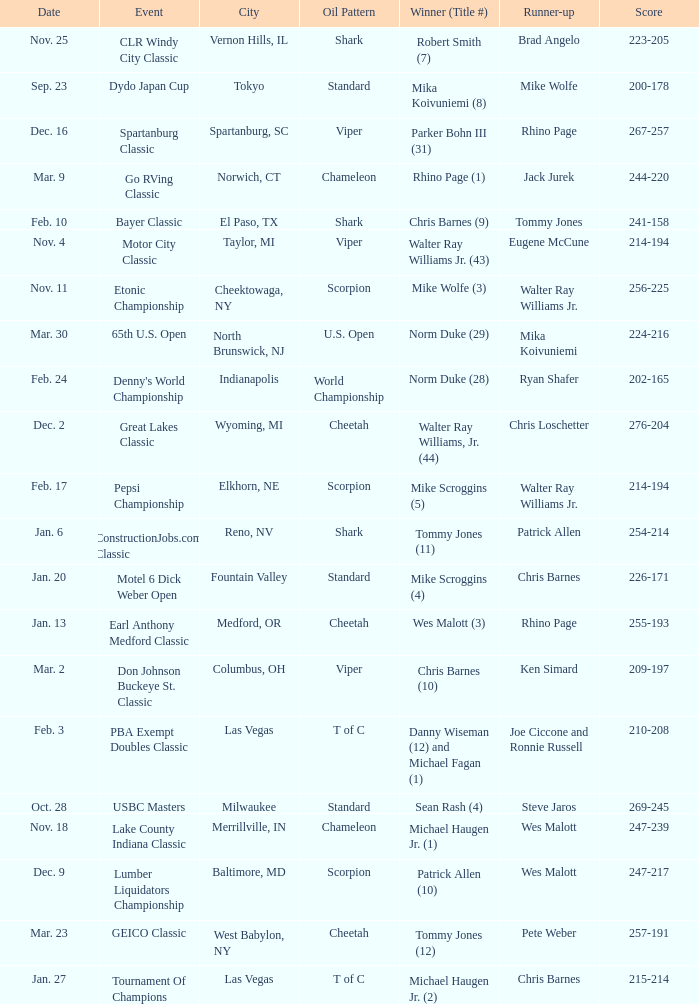Which Score has an Event of constructionjobs.com classic? 254-214. 